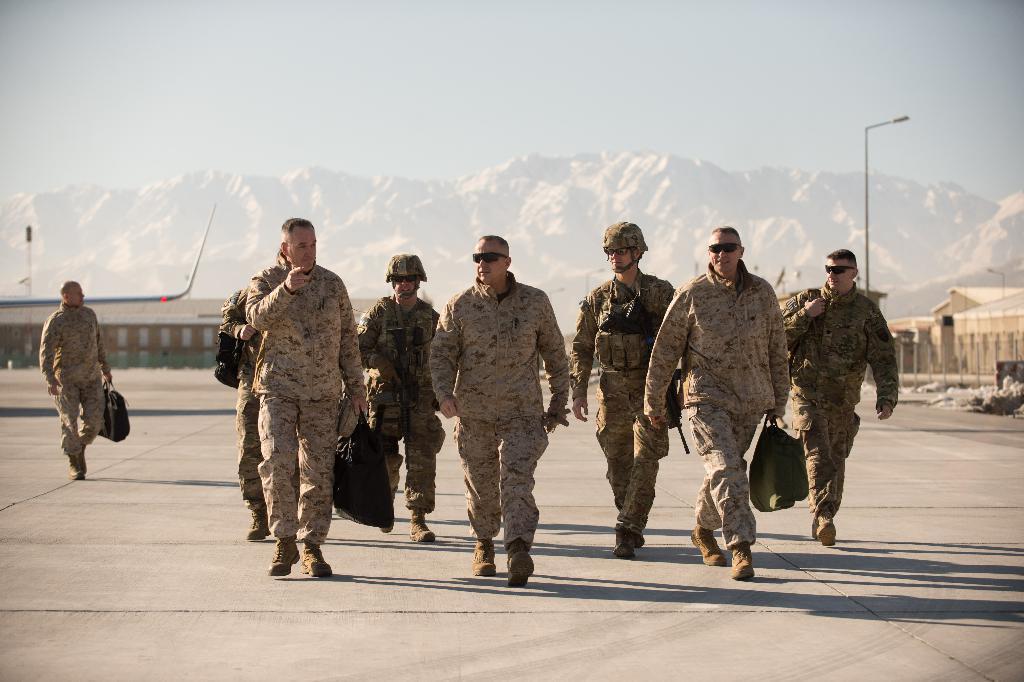Can you describe this image briefly? There are soldiers walking in the foreground area of the image, it seems like houses, poles, mountains and the sky in the background. 